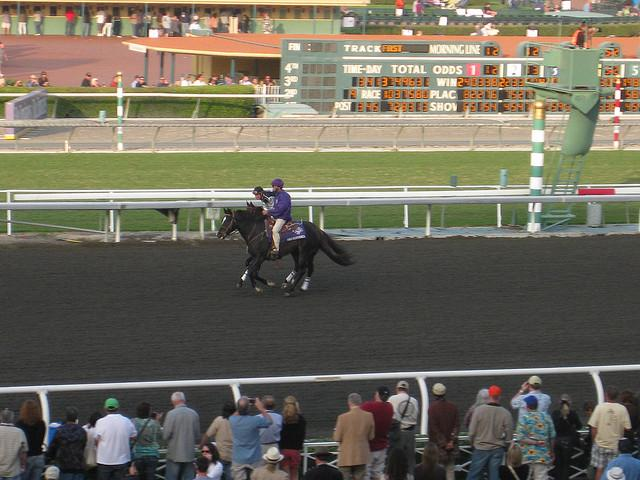What type of event is being held?

Choices:
A) play
B) race
C) concert
D) parade race 